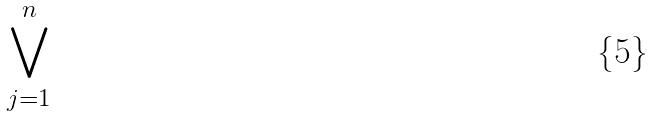<formula> <loc_0><loc_0><loc_500><loc_500>\bigvee _ { j = 1 } ^ { n }</formula> 